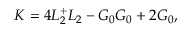Convert formula to latex. <formula><loc_0><loc_0><loc_500><loc_500>K = 4 L _ { 2 } ^ { + } L _ { 2 } - G _ { 0 } G _ { 0 } + 2 G _ { 0 } ,</formula> 